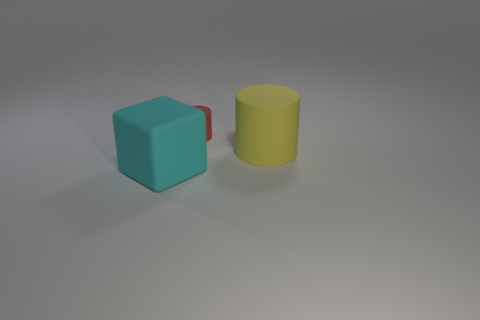Add 3 big red metallic spheres. How many objects exist? 6 Subtract all blocks. How many objects are left? 2 Subtract all blue blocks. Subtract all yellow cylinders. How many blocks are left? 1 Subtract all small cylinders. Subtract all tiny matte objects. How many objects are left? 1 Add 3 large cyan matte things. How many large cyan matte things are left? 4 Add 3 big blocks. How many big blocks exist? 4 Subtract 0 purple blocks. How many objects are left? 3 